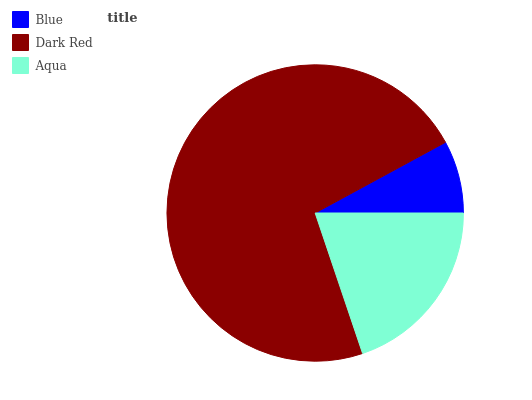Is Blue the minimum?
Answer yes or no. Yes. Is Dark Red the maximum?
Answer yes or no. Yes. Is Aqua the minimum?
Answer yes or no. No. Is Aqua the maximum?
Answer yes or no. No. Is Dark Red greater than Aqua?
Answer yes or no. Yes. Is Aqua less than Dark Red?
Answer yes or no. Yes. Is Aqua greater than Dark Red?
Answer yes or no. No. Is Dark Red less than Aqua?
Answer yes or no. No. Is Aqua the high median?
Answer yes or no. Yes. Is Aqua the low median?
Answer yes or no. Yes. Is Blue the high median?
Answer yes or no. No. Is Blue the low median?
Answer yes or no. No. 